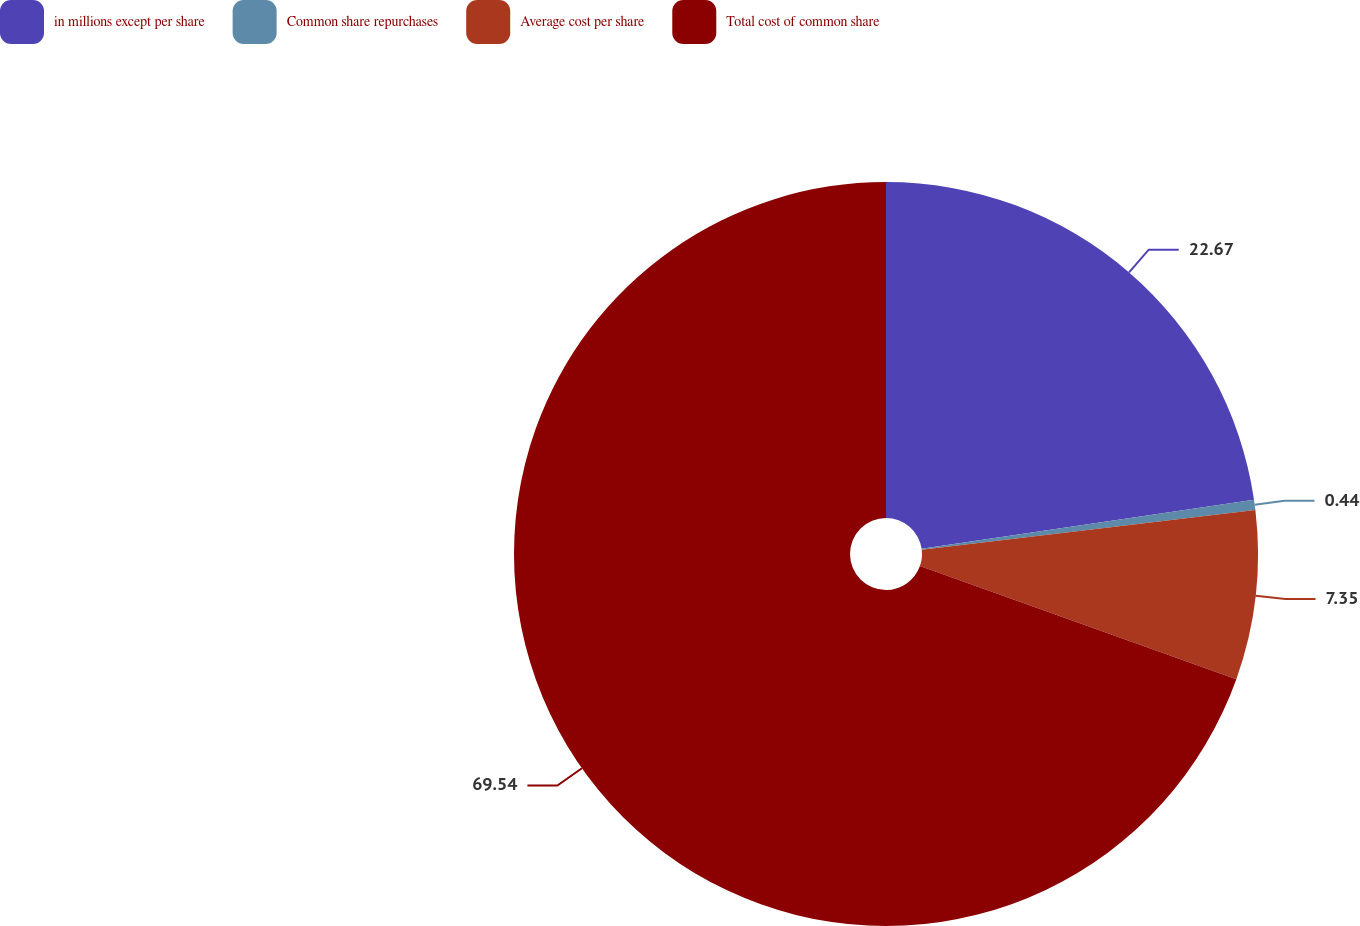Convert chart. <chart><loc_0><loc_0><loc_500><loc_500><pie_chart><fcel>in millions except per share<fcel>Common share repurchases<fcel>Average cost per share<fcel>Total cost of common share<nl><fcel>22.67%<fcel>0.44%<fcel>7.35%<fcel>69.54%<nl></chart> 